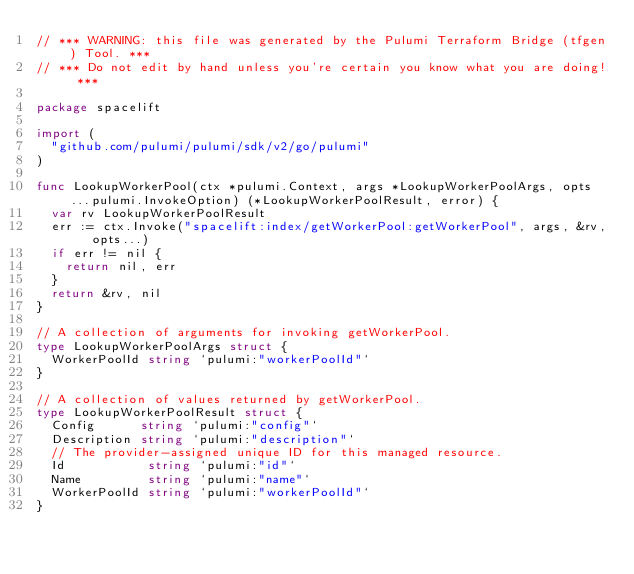Convert code to text. <code><loc_0><loc_0><loc_500><loc_500><_Go_>// *** WARNING: this file was generated by the Pulumi Terraform Bridge (tfgen) Tool. ***
// *** Do not edit by hand unless you're certain you know what you are doing! ***

package spacelift

import (
	"github.com/pulumi/pulumi/sdk/v2/go/pulumi"
)

func LookupWorkerPool(ctx *pulumi.Context, args *LookupWorkerPoolArgs, opts ...pulumi.InvokeOption) (*LookupWorkerPoolResult, error) {
	var rv LookupWorkerPoolResult
	err := ctx.Invoke("spacelift:index/getWorkerPool:getWorkerPool", args, &rv, opts...)
	if err != nil {
		return nil, err
	}
	return &rv, nil
}

// A collection of arguments for invoking getWorkerPool.
type LookupWorkerPoolArgs struct {
	WorkerPoolId string `pulumi:"workerPoolId"`
}

// A collection of values returned by getWorkerPool.
type LookupWorkerPoolResult struct {
	Config      string `pulumi:"config"`
	Description string `pulumi:"description"`
	// The provider-assigned unique ID for this managed resource.
	Id           string `pulumi:"id"`
	Name         string `pulumi:"name"`
	WorkerPoolId string `pulumi:"workerPoolId"`
}
</code> 